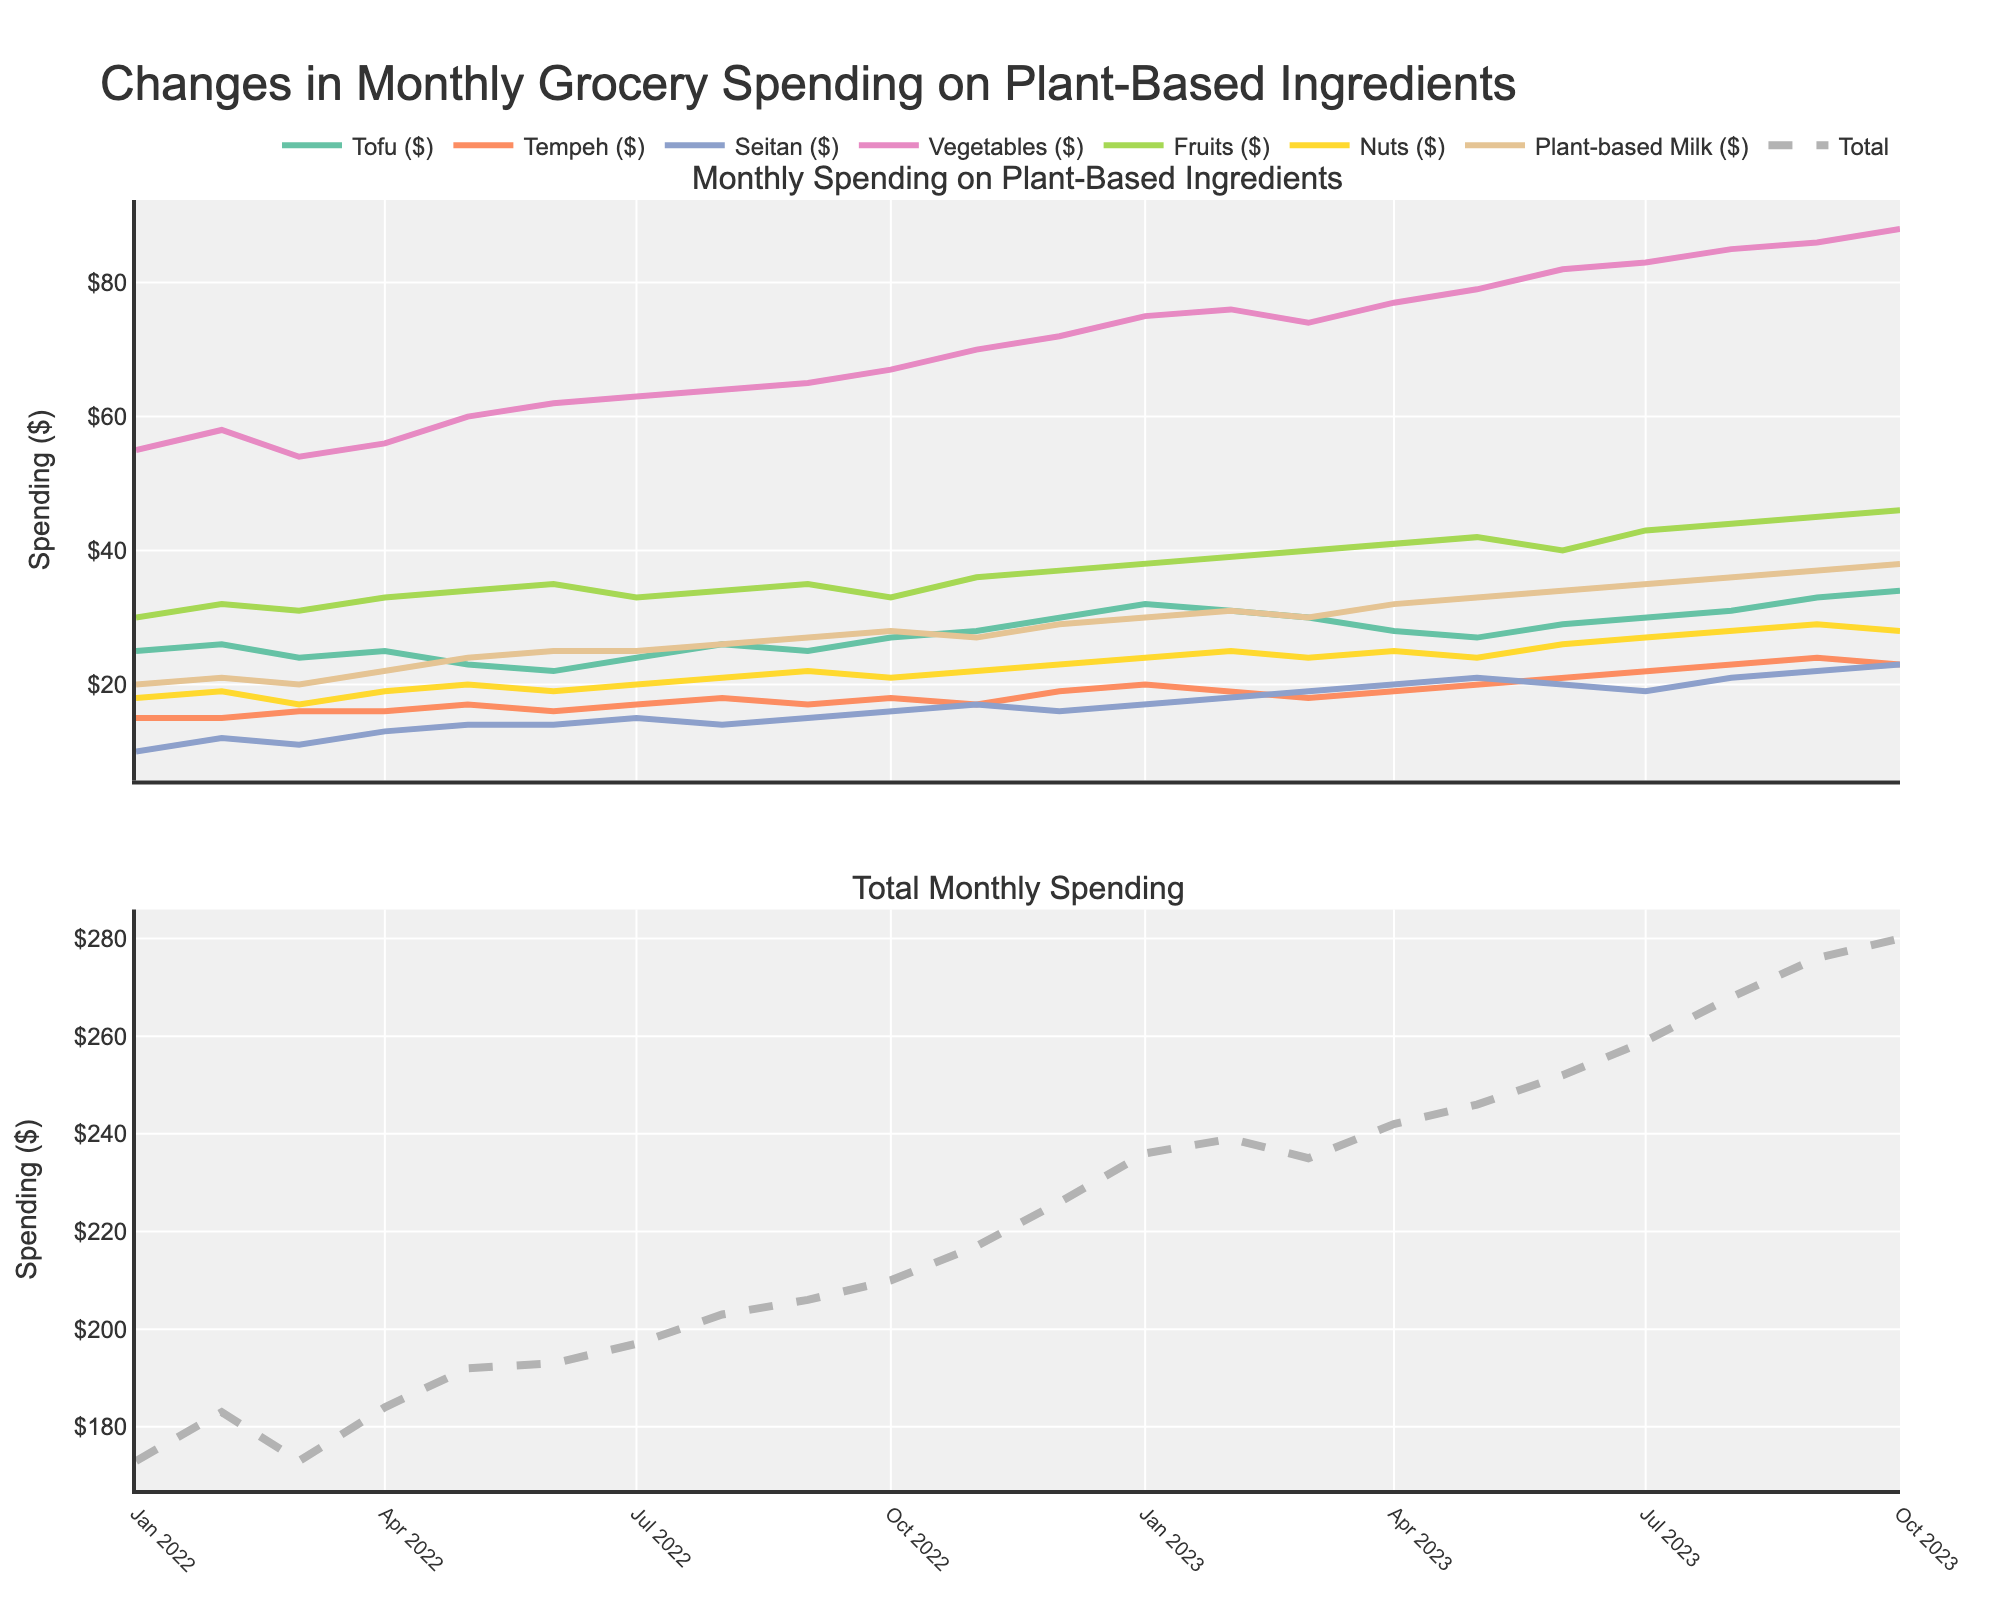What is the title of the plot? The plot title is displayed at the top of the figure. It reads "Changes in Monthly Grocery Spending on Plant-Based Ingredients".
Answer: Changes in Monthly Grocery Spending on Plant-Based Ingredients What is the overall trend of total monthly spending from January 2022 to October 2023? By looking at the second subplot, we can observe that the total monthly spending shows an upward trend from January 2022 to October 2023, increasing from $173 to $280.
Answer: Upward trend What was the highest monthly spending on vegetables, and when did it occur? In the first subplot, the highest value for vegetables can be observed in October 2023 at $88.
Answer: $88 in October 2023 Compare the spending on tofu and tempeh in July 2023. Which one had higher spending and by how much? On the first subplot, for July 2023, the spending on tofu is $30, while on tempeh it is $22. The difference is $8 with tofu having higher spending.
Answer: Tofu by $8 During which months did the total spending exceed $250? In the second subplot, the total spending exceeds $250 in June 2023, July 2023, August 2023, September 2023, and October 2023.
Answer: June 2023, July 2023, August 2023, September 2023, October 2023 What is the month-to-month increase in total spending from January 2023 to February 2023? For January 2023, the total spending is $236. For February 2023, it is $239. The increase is $239 - $236 = $3.
Answer: $3 How has the spending on plant-based milk changed from January 2022 to October 2023? In the first subplot, the spending on plant-based milk starts at $20 in January 2022 and increases to $38 by October 2023, showing a consistent upward trend.
Answer: Increased What is the average spending on fruits over the entire period? Sum the spending on fruits for all months and divide by the number of months. Total sum of fruit spending from January 2022 to October 2023 is $766. There are 22 months, so the average is $766/22 = $34.82.
Answer: $34.82 Which ingredient had the most significant increase in spending from the start to the end of the period? By comparing the spending in January 2022 and October 2023 for each ingredient, plant-based milk had an increase from $20 to $38, which is a significant rise of $18, and appears to be the highest increase.
Answer: Plant-based Milk What's the difference in total spending between May 2023 and May 2022? In May 2023, total spending is $246. In May 2022, it is $192. The difference is $246 - $192 = $54.
Answer: $54 